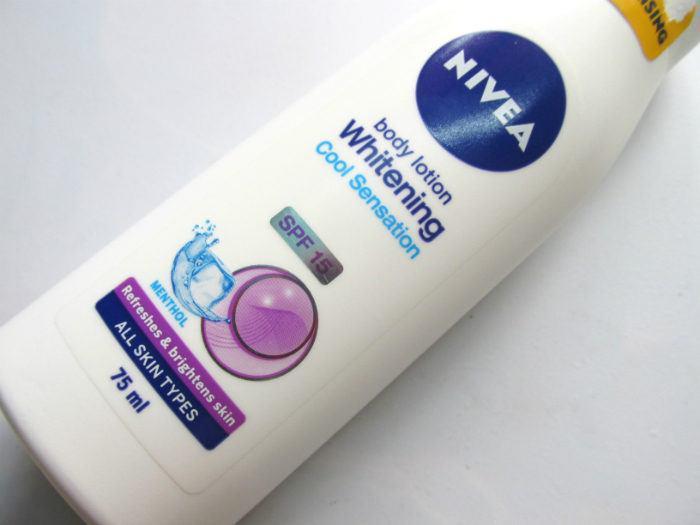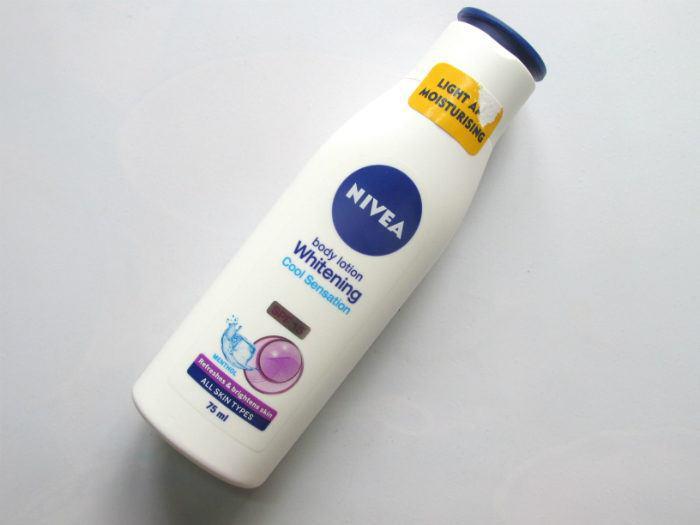The first image is the image on the left, the second image is the image on the right. Given the left and right images, does the statement "There is a torn sticker on the bottle in the image on the left." hold true? Answer yes or no. Yes. 